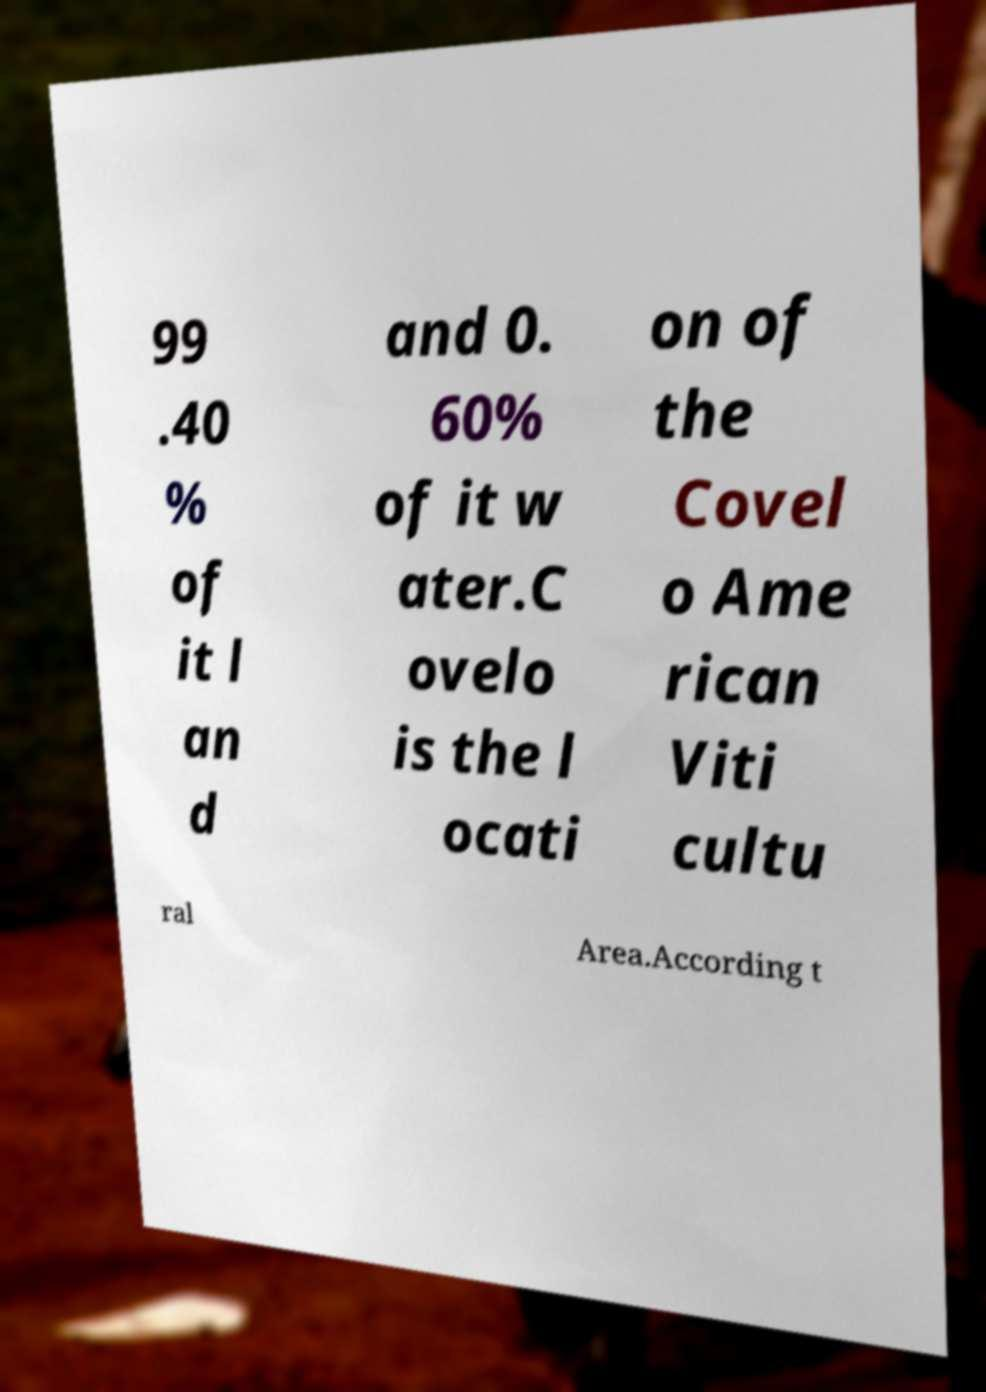There's text embedded in this image that I need extracted. Can you transcribe it verbatim? 99 .40 % of it l an d and 0. 60% of it w ater.C ovelo is the l ocati on of the Covel o Ame rican Viti cultu ral Area.According t 